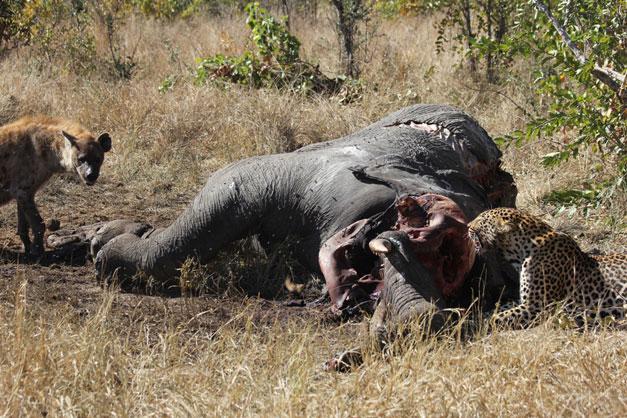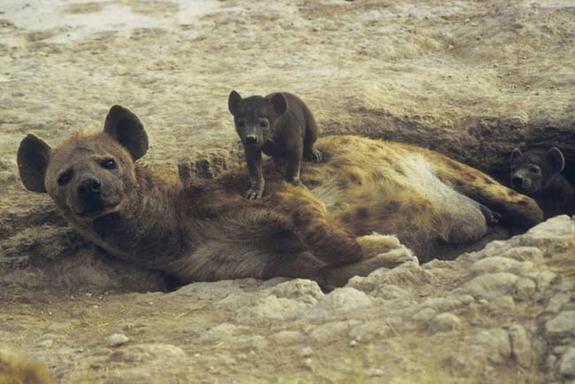The first image is the image on the left, the second image is the image on the right. Analyze the images presented: Is the assertion "An image shows an adult hyena lying down horizontally with head to the left, in close proximity to at least one hyena pup." valid? Answer yes or no. Yes. The first image is the image on the left, the second image is the image on the right. Considering the images on both sides, is "One hyena is lying on the ground with a baby near it in the image on the right." valid? Answer yes or no. Yes. 